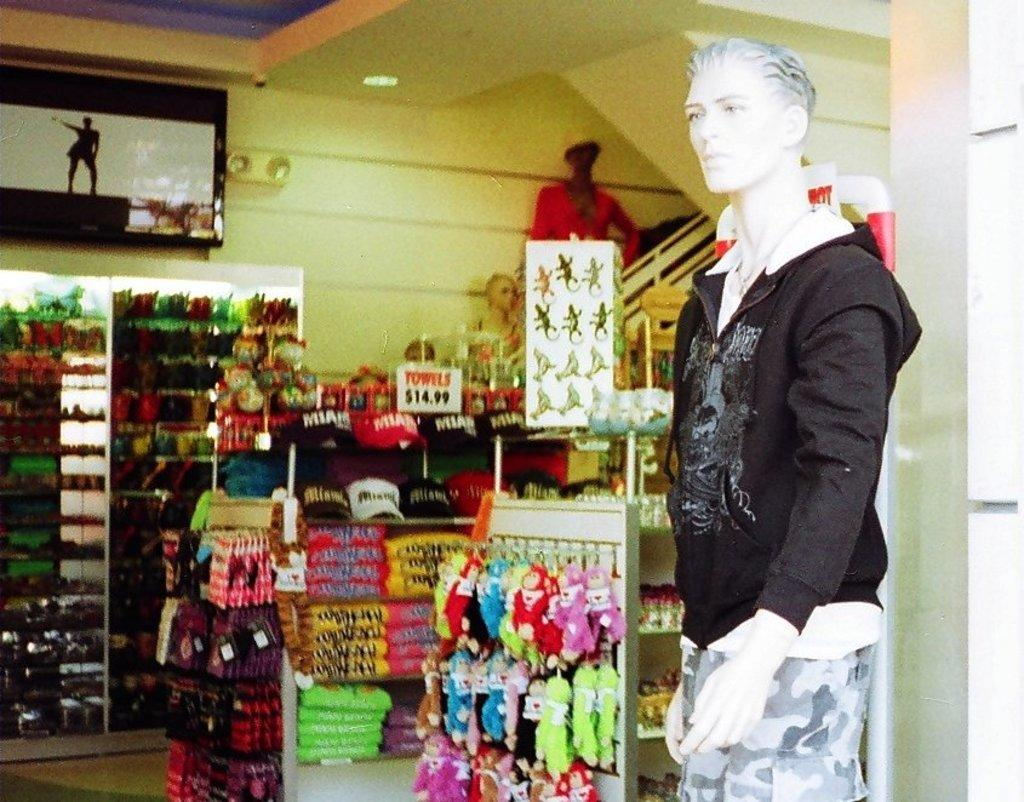What type of establishment is shown in the image? There is a store in the image. What items can be seen inside the store? There are multiple caps with different colors in the image. What tool is visible in the image? There is a rake in the image. What figure is standing in front of the store? There is a mannequin standing in front of the store. What electronic device is present in the image? There is a television in the image. What time of day is it in the image, given the presence of a carriage? There is no carriage present in the image, so it is not possible to determine the time of day based on that information. 